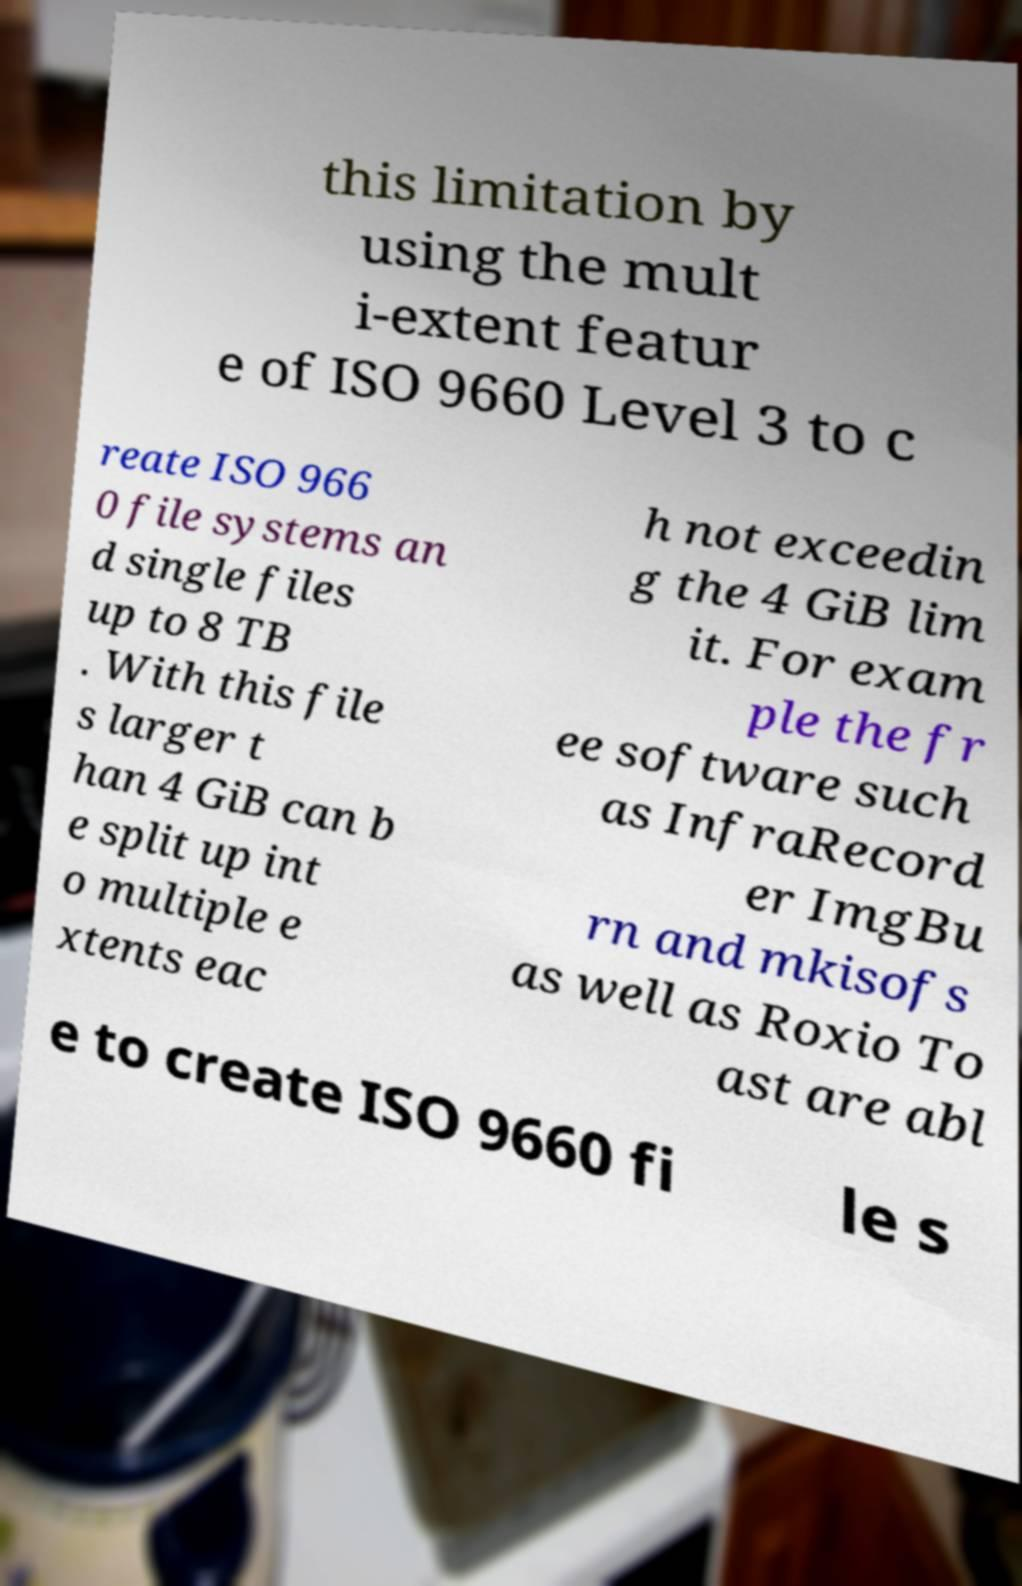Can you accurately transcribe the text from the provided image for me? this limitation by using the mult i-extent featur e of ISO 9660 Level 3 to c reate ISO 966 0 file systems an d single files up to 8 TB . With this file s larger t han 4 GiB can b e split up int o multiple e xtents eac h not exceedin g the 4 GiB lim it. For exam ple the fr ee software such as InfraRecord er ImgBu rn and mkisofs as well as Roxio To ast are abl e to create ISO 9660 fi le s 